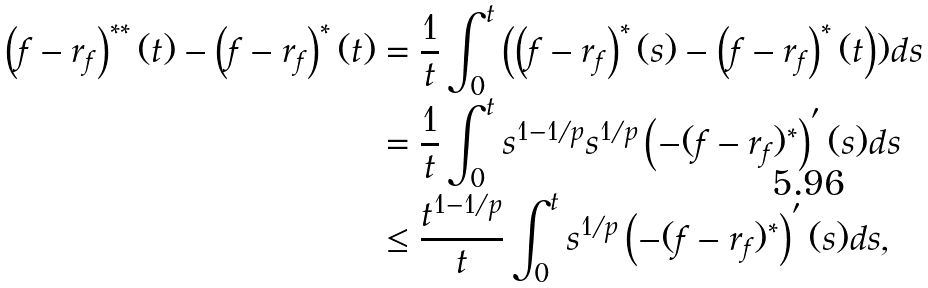<formula> <loc_0><loc_0><loc_500><loc_500>\left ( f - r _ { f } \right ) ^ { \ast \ast } ( t ) - \left ( f - r _ { f } \right ) ^ { \ast } ( t ) & = \frac { 1 } { t } \int _ { 0 } ^ { t } \left ( \left ( f - r _ { f } \right ) ^ { \ast } ( s ) - \left ( f - r _ { f } \right ) ^ { \ast } ( t \right ) ) d s \\ & = \frac { 1 } { t } \int _ { 0 } ^ { t } s ^ { 1 - 1 / p } s ^ { 1 / p } \left ( - ( f - r _ { f } ) ^ { \ast } \right ) ^ { ^ { \prime } } ( s ) d s \\ & \leq \frac { t ^ { 1 - 1 / p } } { t } \int _ { 0 } ^ { t } s ^ { 1 / p } \left ( - ( f - r _ { f } ) ^ { \ast } \right ) ^ { ^ { \prime } } ( s ) d s ,</formula> 